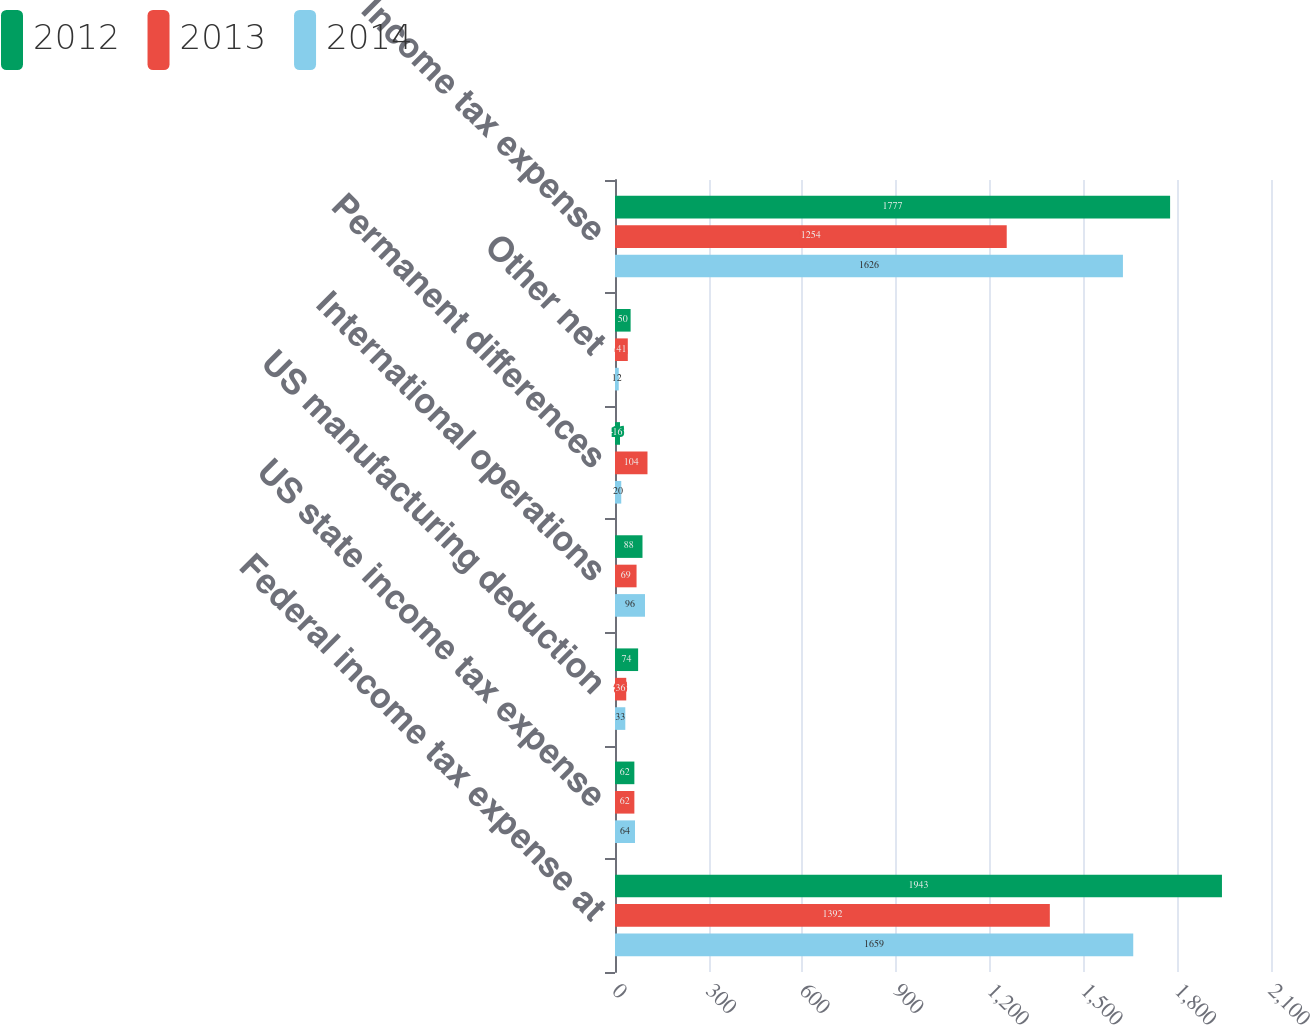Convert chart. <chart><loc_0><loc_0><loc_500><loc_500><stacked_bar_chart><ecel><fcel>Federal income tax expense at<fcel>US state income tax expense<fcel>US manufacturing deduction<fcel>International operations<fcel>Permanent differences<fcel>Other net<fcel>Income tax expense<nl><fcel>2012<fcel>1943<fcel>62<fcel>74<fcel>88<fcel>16<fcel>50<fcel>1777<nl><fcel>2013<fcel>1392<fcel>62<fcel>36<fcel>69<fcel>104<fcel>41<fcel>1254<nl><fcel>2014<fcel>1659<fcel>64<fcel>33<fcel>96<fcel>20<fcel>12<fcel>1626<nl></chart> 